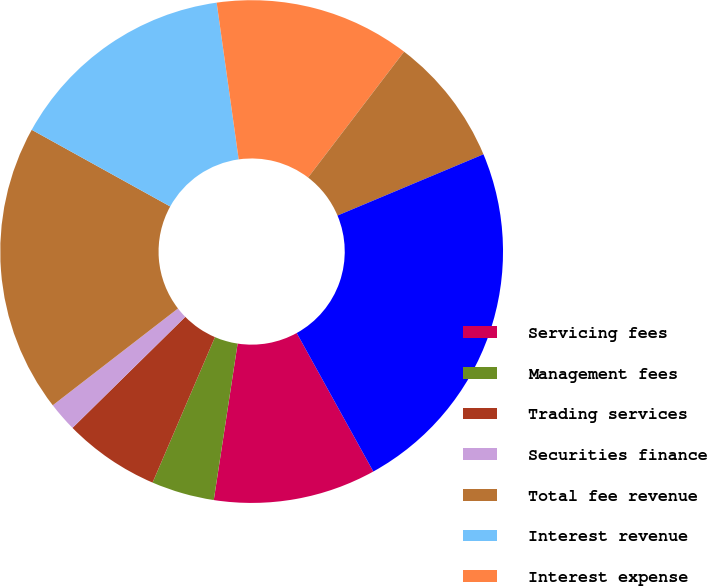<chart> <loc_0><loc_0><loc_500><loc_500><pie_chart><fcel>Servicing fees<fcel>Management fees<fcel>Trading services<fcel>Securities finance<fcel>Total fee revenue<fcel>Interest revenue<fcel>Interest expense<fcel>Net interest revenue<fcel>Total revenue<nl><fcel>10.45%<fcel>4.04%<fcel>6.18%<fcel>1.9%<fcel>18.52%<fcel>14.73%<fcel>12.59%<fcel>8.31%<fcel>23.28%<nl></chart> 